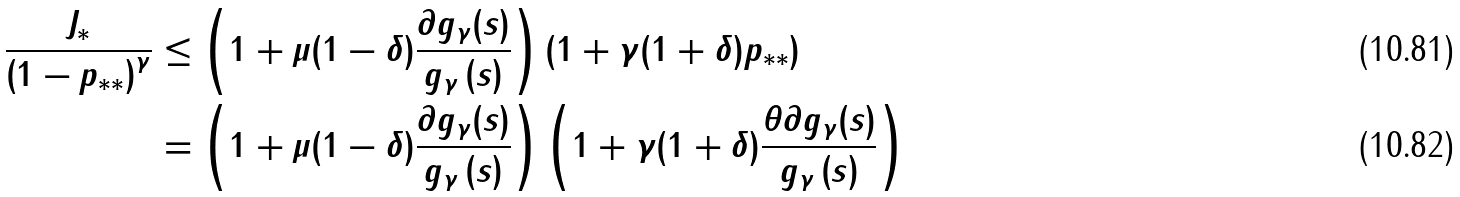<formula> <loc_0><loc_0><loc_500><loc_500>\frac { J _ { \ast } } { \left ( 1 - p _ { \ast \ast } \right ) ^ { \gamma } } & \leq \left ( 1 + \mu ( 1 - \delta ) \frac { \partial g _ { \gamma } ( s ) } { g _ { \gamma } \left ( s \right ) } \right ) ( 1 + \gamma ( 1 + \delta ) p _ { \ast \ast } ) \\ & = \left ( 1 + \mu ( 1 - \delta ) \frac { \partial g _ { \gamma } ( s ) } { g _ { \gamma } \left ( s \right ) } \right ) \left ( 1 + \gamma ( 1 + \delta ) \frac { \theta \partial g _ { \gamma } ( s ) } { g _ { \gamma } \left ( s \right ) } \right )</formula> 